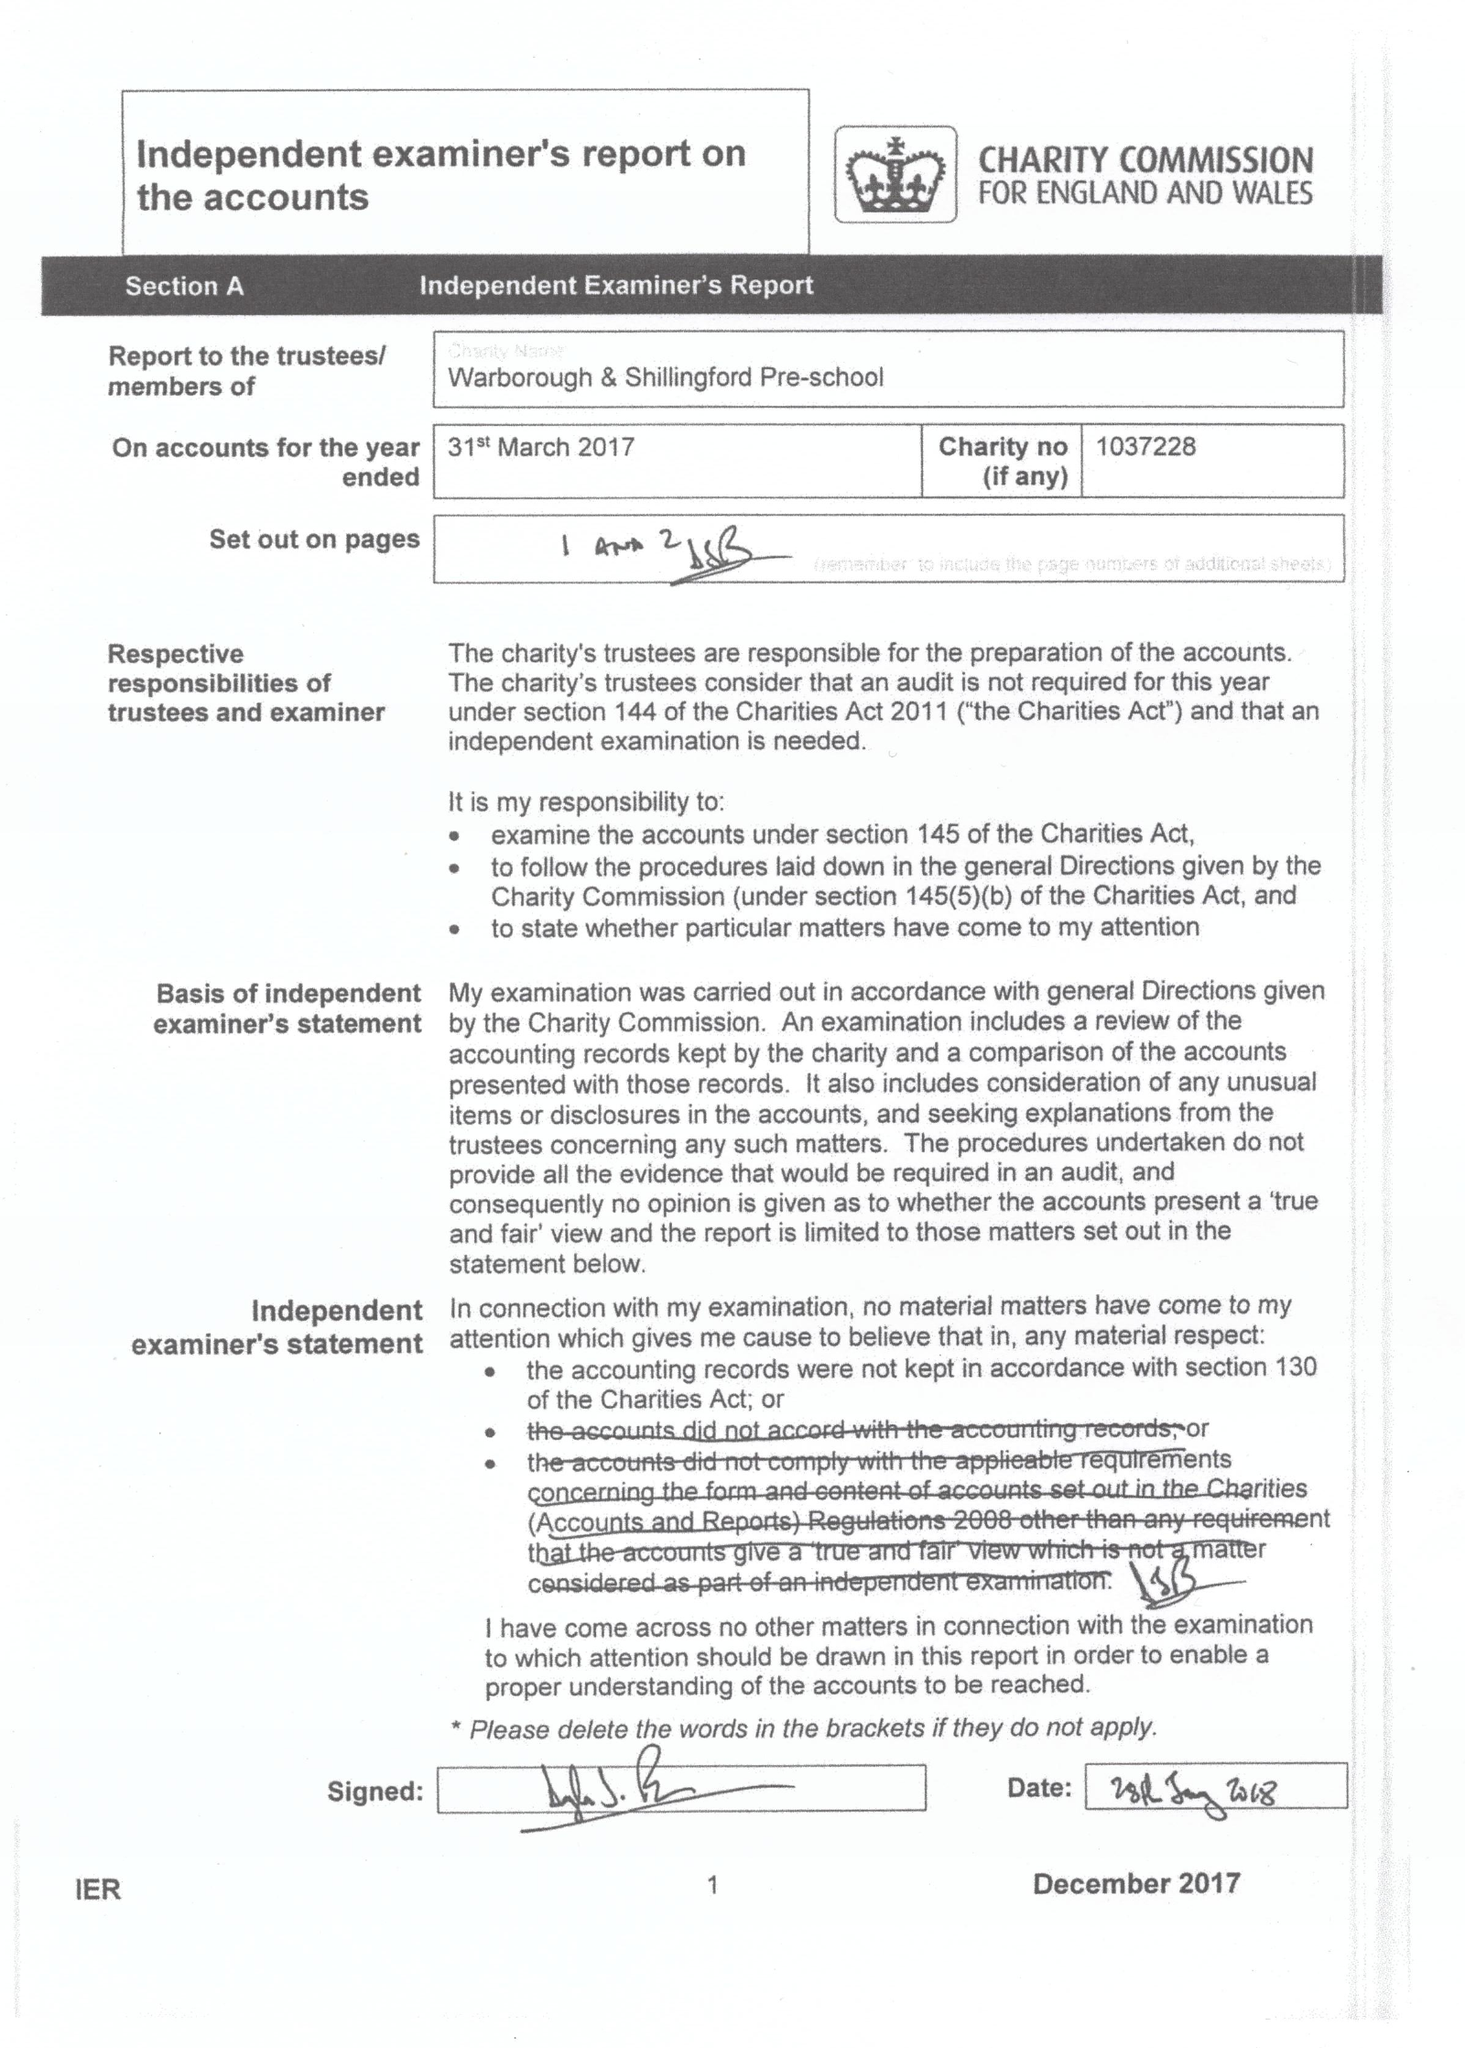What is the value for the address__post_town?
Answer the question using a single word or phrase. WALLINGFORD 